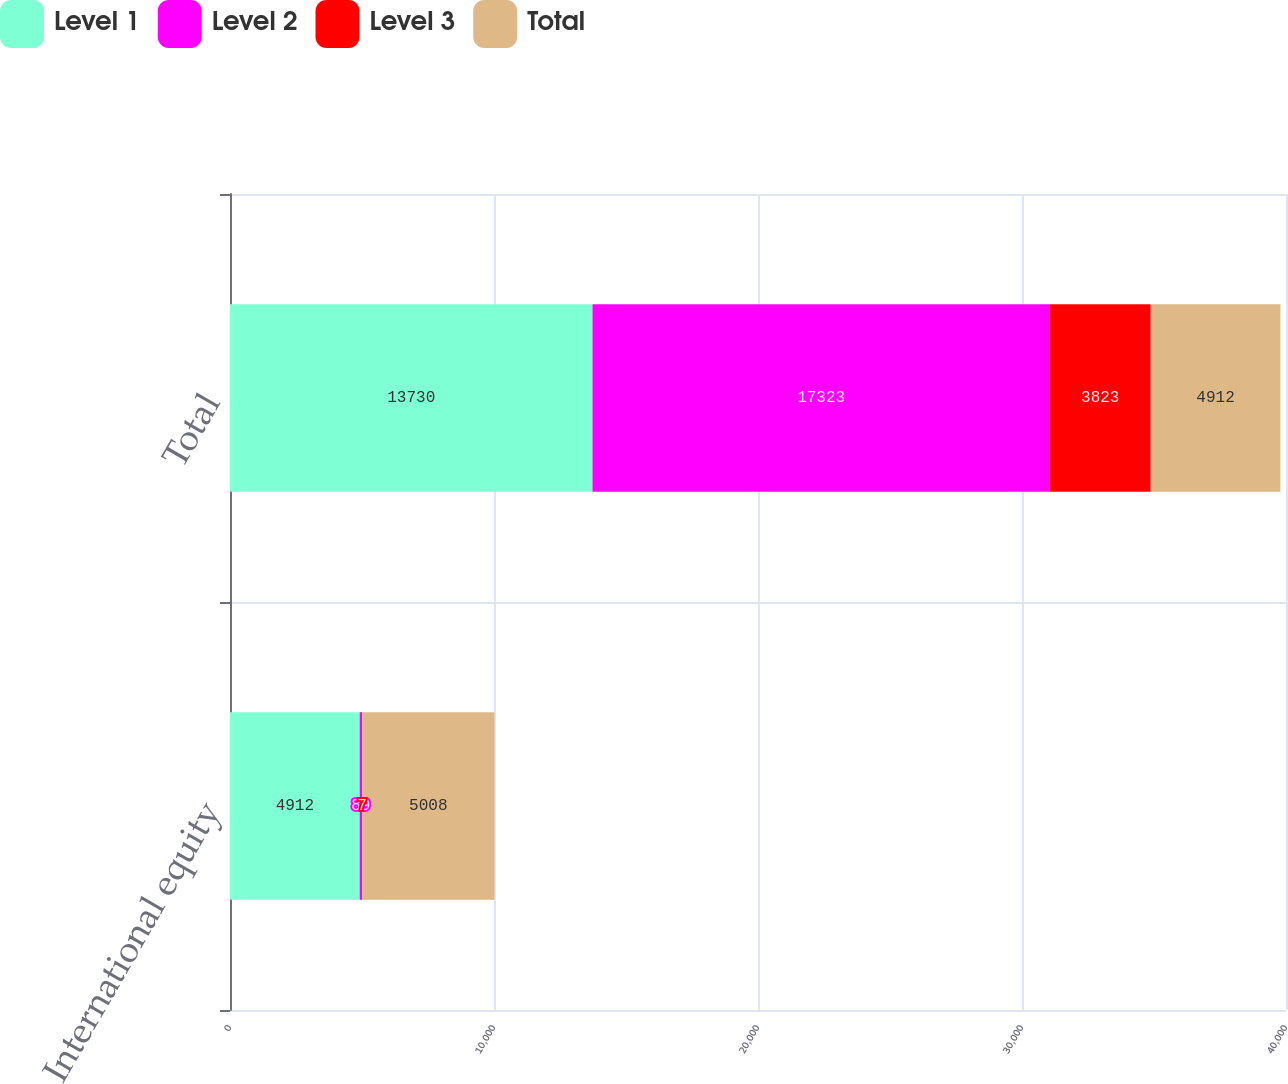Convert chart. <chart><loc_0><loc_0><loc_500><loc_500><stacked_bar_chart><ecel><fcel>International equity<fcel>Total<nl><fcel>Level 1<fcel>4912<fcel>13730<nl><fcel>Level 2<fcel>89<fcel>17323<nl><fcel>Level 3<fcel>7<fcel>3823<nl><fcel>Total<fcel>5008<fcel>4912<nl></chart> 